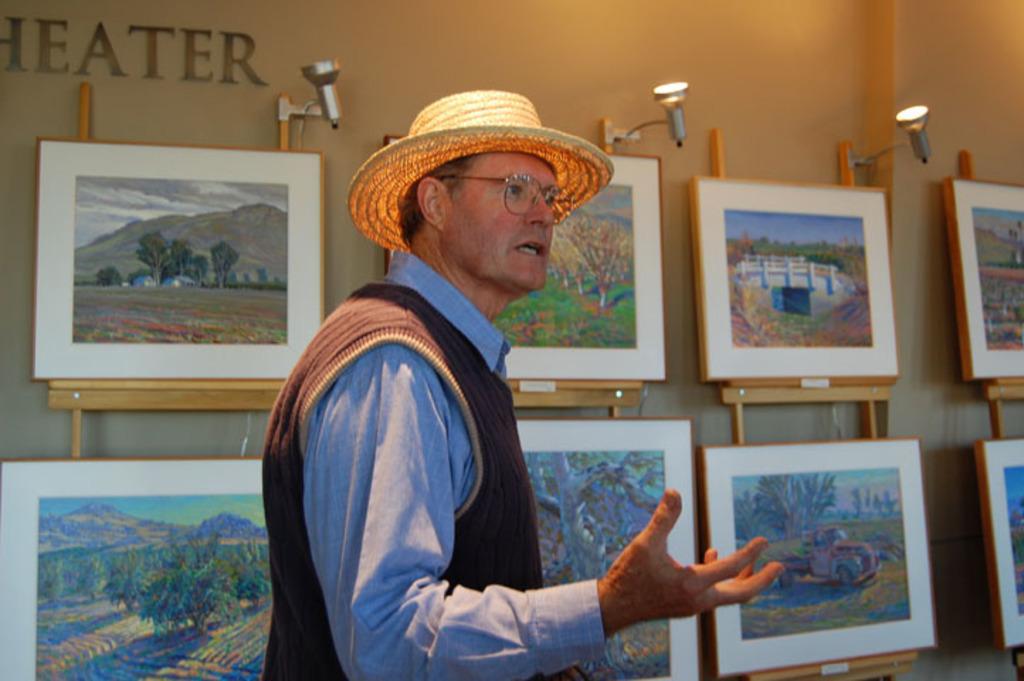In one or two sentences, can you explain what this image depicts? In this image I can see a man in the front, I can see he is wearing a hat, a specs, shirt and half sleeve sweater. In the background I can see number of paintings, three lights and on the top left side of this image I can see something is written on the wall. 